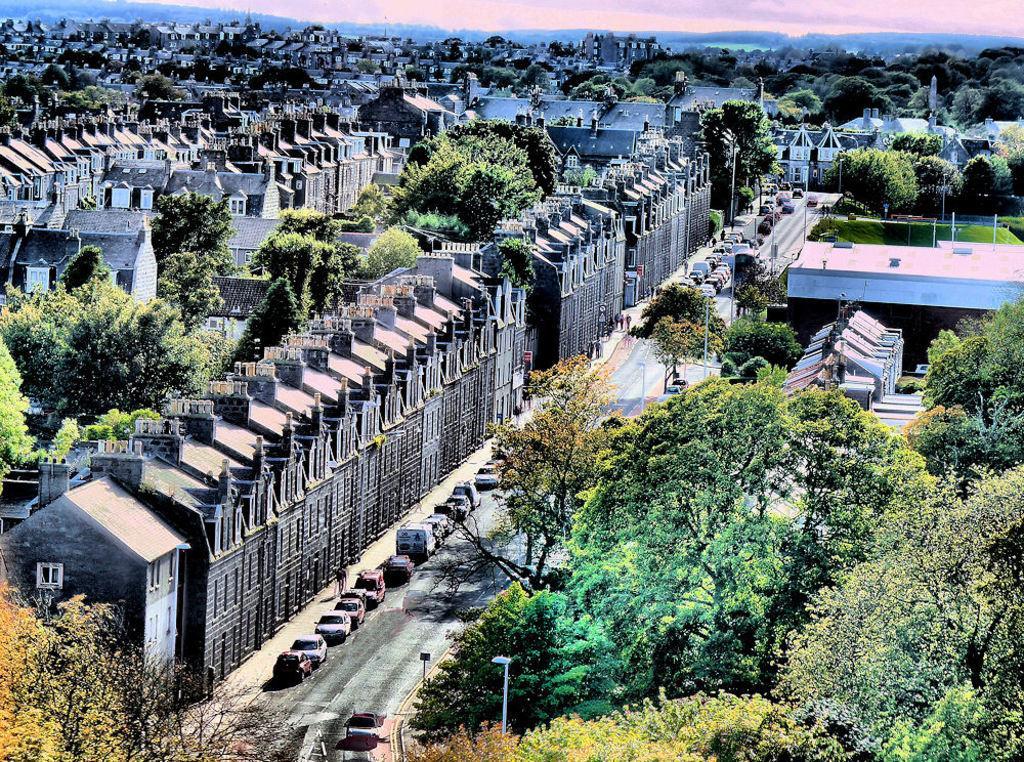Please provide a concise description of this image. In this picture there are buildings and trees and poles and there are vehicles on the road. At the back there are mountains. At the top there is sky and there are clouds. 